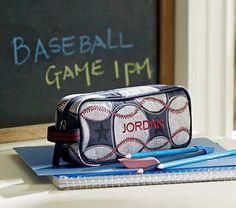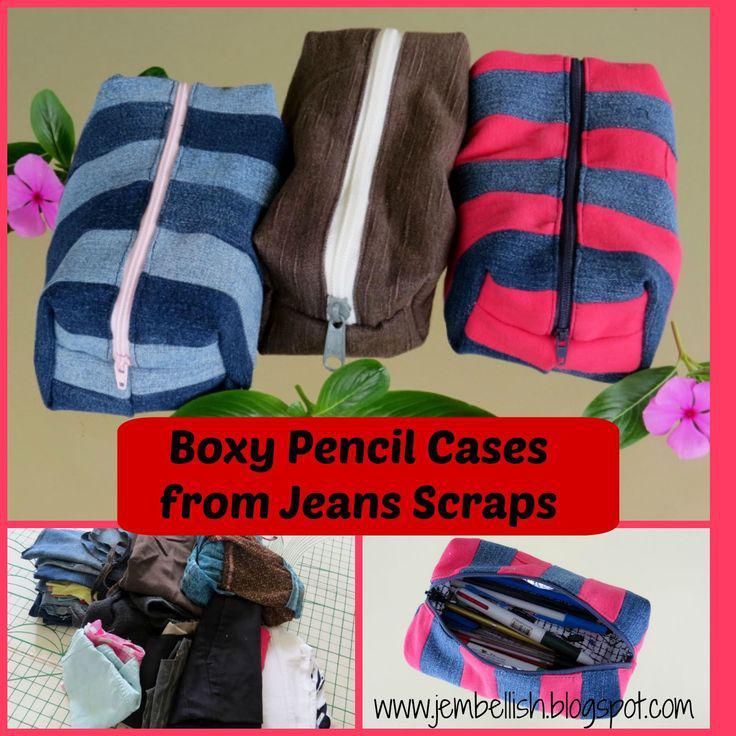The first image is the image on the left, the second image is the image on the right. For the images shown, is this caption "At least one image features a pencil holder made of jean denim, and an image shows a pencil holder atop a stack of paper items." true? Answer yes or no. Yes. The first image is the image on the left, the second image is the image on the right. For the images shown, is this caption "Pencils sit horizontally in a container in the image on the left." true? Answer yes or no. No. 